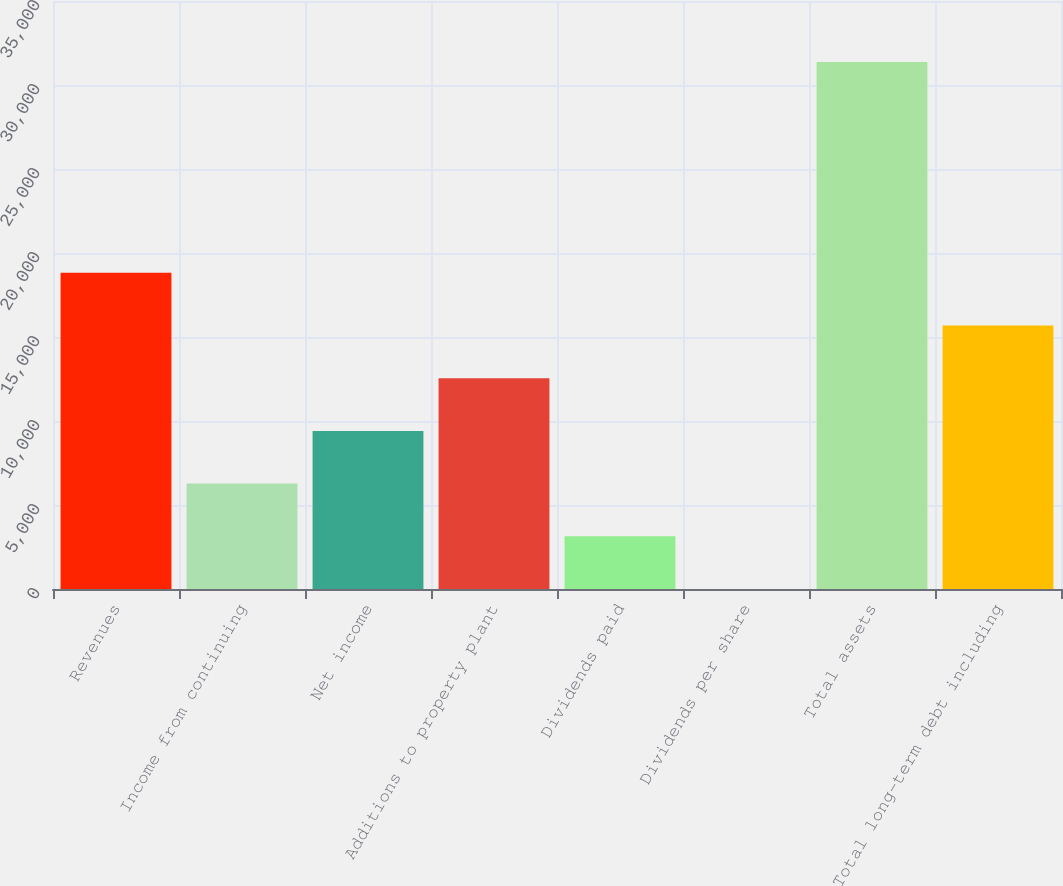Convert chart to OTSL. <chart><loc_0><loc_0><loc_500><loc_500><bar_chart><fcel>Revenues<fcel>Income from continuing<fcel>Net income<fcel>Additions to property plant<fcel>Dividends paid<fcel>Dividends per share<fcel>Total assets<fcel>Total long-term debt including<nl><fcel>18822.9<fcel>6274.84<fcel>9411.86<fcel>12548.9<fcel>3137.82<fcel>0.8<fcel>31371<fcel>15685.9<nl></chart> 